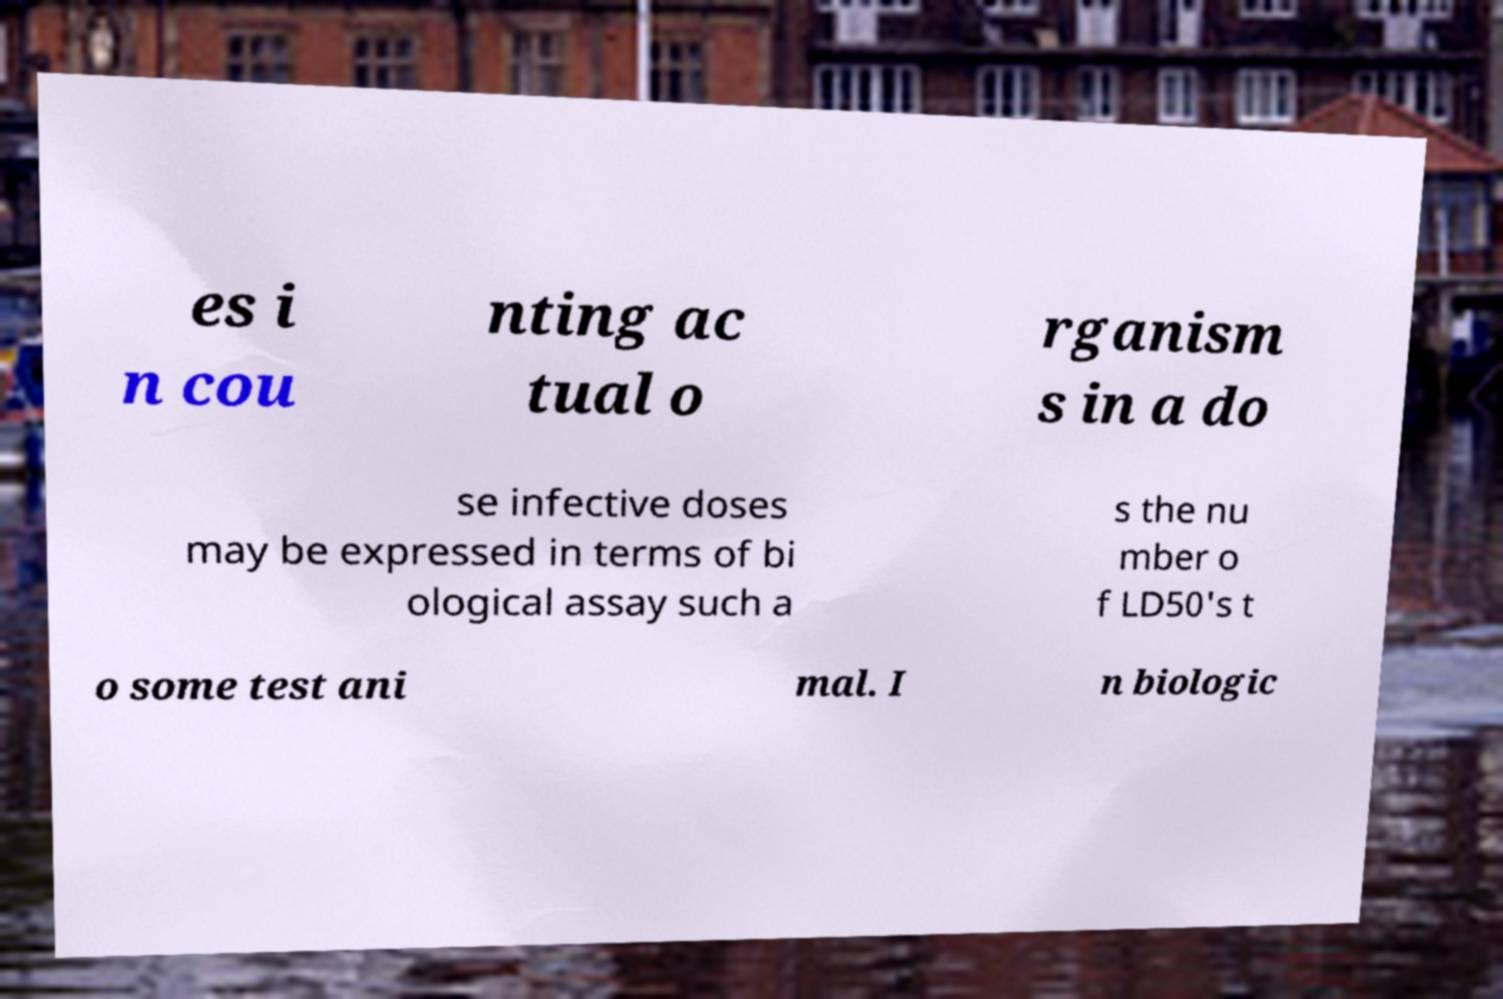I need the written content from this picture converted into text. Can you do that? es i n cou nting ac tual o rganism s in a do se infective doses may be expressed in terms of bi ological assay such a s the nu mber o f LD50's t o some test ani mal. I n biologic 